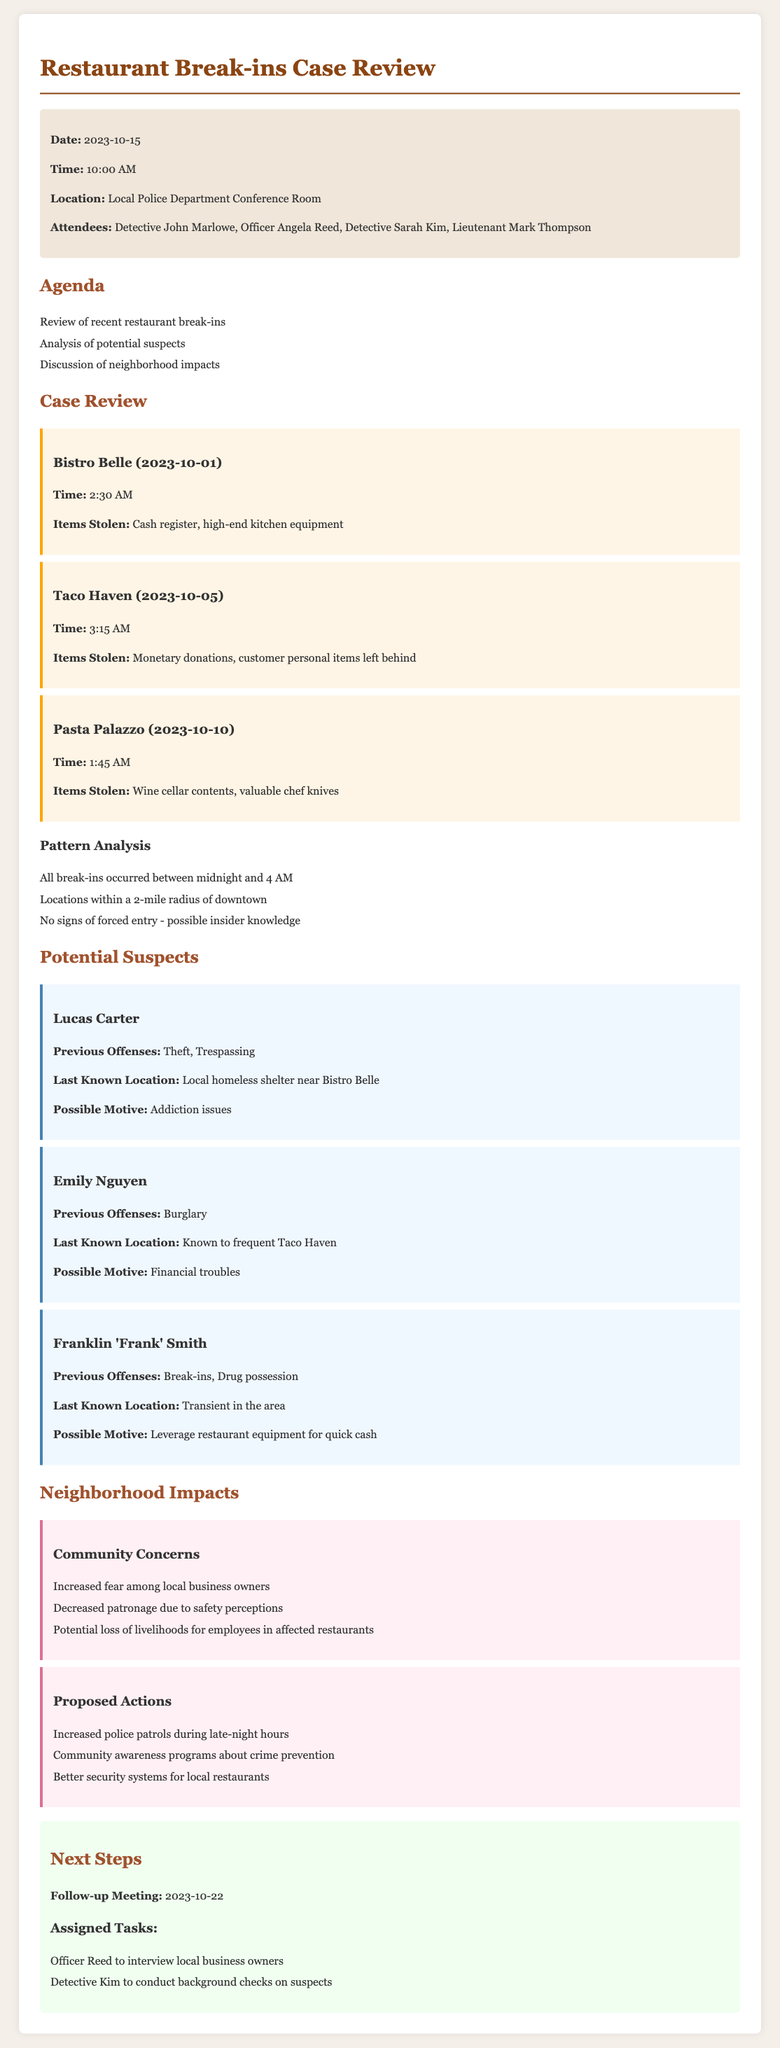What date was the meeting held? The meeting date is mentioned in the meta-info section of the document.
Answer: 2023-10-15 What time did the meeting start? The time the meeting started is provided in the meta-info section.
Answer: 10:00 AM Which restaurant was broken into on October 1, 2023? The details of the incidents list the names and dates of the establishments affected.
Answer: Bistro Belle How many incidents of break-ins were reviewed? The incidents section lists the number of break-ins discussed.
Answer: Three What is the primary motive for Lucas Carter's potential involvement? The possible motives for the suspects are outlined in the potential suspects section.
Answer: Addiction issues What impact is highlighted regarding local business owners? The community concerns section discusses the effects on local businesses.
Answer: Increased fear among local business owners Who is assigned to interview local business owners? The next steps section specifies the tasks assigned to different participants.
Answer: Officer Reed What security measure is proposed for local restaurants? The proposed actions provide suggestions for improving security in the neighborhood.
Answer: Better security systems for local restaurants What is the date of the follow-up meeting? The follow-up meeting date is explicitly stated in the next steps section.
Answer: 2023-10-22 